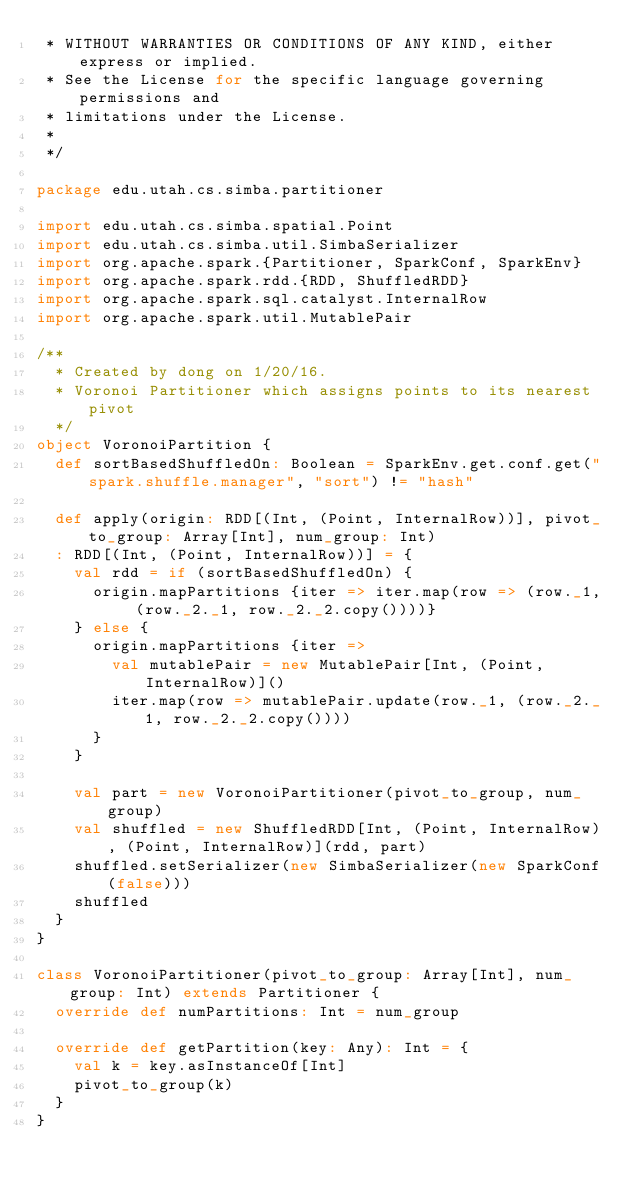<code> <loc_0><loc_0><loc_500><loc_500><_Scala_> * WITHOUT WARRANTIES OR CONDITIONS OF ANY KIND, either express or implied.
 * See the License for the specific language governing permissions and
 * limitations under the License.
 *
 */

package edu.utah.cs.simba.partitioner

import edu.utah.cs.simba.spatial.Point
import edu.utah.cs.simba.util.SimbaSerializer
import org.apache.spark.{Partitioner, SparkConf, SparkEnv}
import org.apache.spark.rdd.{RDD, ShuffledRDD}
import org.apache.spark.sql.catalyst.InternalRow
import org.apache.spark.util.MutablePair

/**
  * Created by dong on 1/20/16.
  * Voronoi Partitioner which assigns points to its nearest pivot
  */
object VoronoiPartition {
  def sortBasedShuffledOn: Boolean = SparkEnv.get.conf.get("spark.shuffle.manager", "sort") != "hash"

  def apply(origin: RDD[(Int, (Point, InternalRow))], pivot_to_group: Array[Int], num_group: Int)
  : RDD[(Int, (Point, InternalRow))] = {
    val rdd = if (sortBasedShuffledOn) {
      origin.mapPartitions {iter => iter.map(row => (row._1, (row._2._1, row._2._2.copy())))}
    } else {
      origin.mapPartitions {iter =>
        val mutablePair = new MutablePair[Int, (Point, InternalRow)]()
        iter.map(row => mutablePair.update(row._1, (row._2._1, row._2._2.copy())))
      }
    }

    val part = new VoronoiPartitioner(pivot_to_group, num_group)
    val shuffled = new ShuffledRDD[Int, (Point, InternalRow), (Point, InternalRow)](rdd, part)
    shuffled.setSerializer(new SimbaSerializer(new SparkConf(false)))
    shuffled
  }
}

class VoronoiPartitioner(pivot_to_group: Array[Int], num_group: Int) extends Partitioner {
  override def numPartitions: Int = num_group

  override def getPartition(key: Any): Int = {
    val k = key.asInstanceOf[Int]
    pivot_to_group(k)
  }
}
</code> 